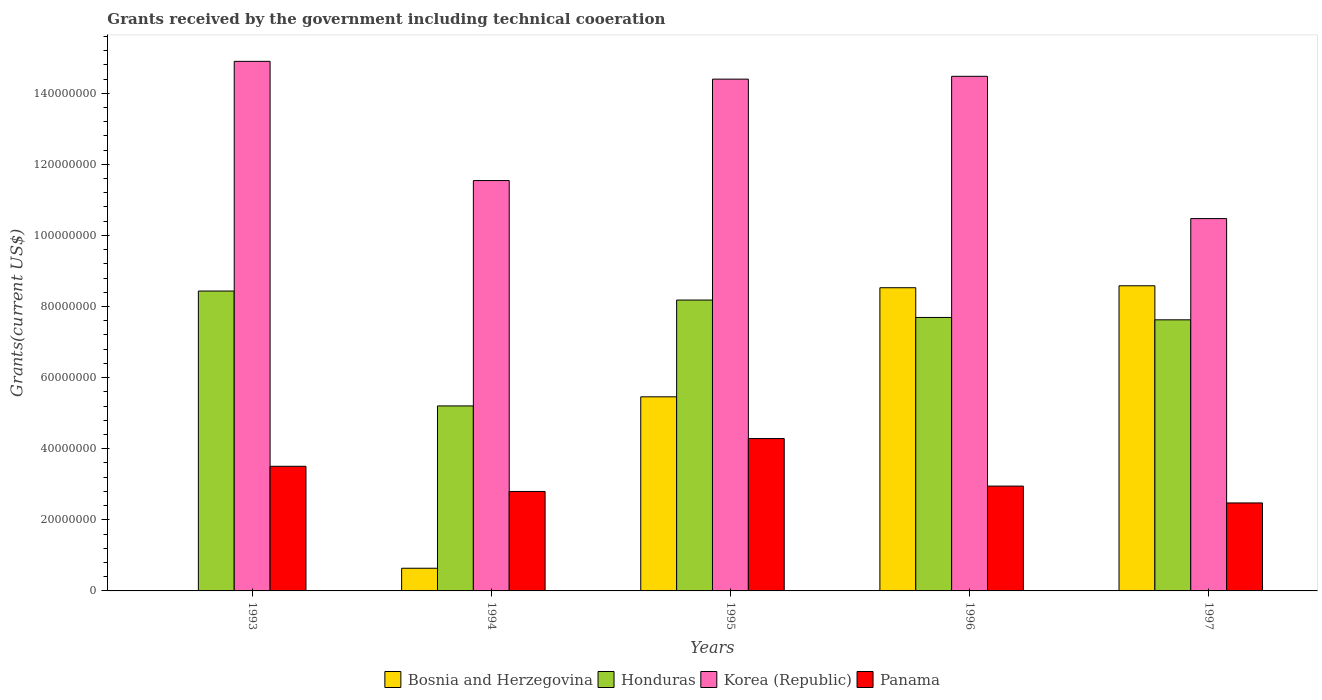Are the number of bars per tick equal to the number of legend labels?
Give a very brief answer. Yes. What is the label of the 4th group of bars from the left?
Provide a short and direct response. 1996. In how many cases, is the number of bars for a given year not equal to the number of legend labels?
Make the answer very short. 0. What is the total grants received by the government in Honduras in 1993?
Make the answer very short. 8.44e+07. Across all years, what is the maximum total grants received by the government in Panama?
Ensure brevity in your answer.  4.29e+07. Across all years, what is the minimum total grants received by the government in Honduras?
Offer a terse response. 5.20e+07. What is the total total grants received by the government in Panama in the graph?
Keep it short and to the point. 1.60e+08. What is the difference between the total grants received by the government in Panama in 1994 and that in 1996?
Give a very brief answer. -1.51e+06. What is the difference between the total grants received by the government in Korea (Republic) in 1993 and the total grants received by the government in Honduras in 1994?
Your answer should be very brief. 9.69e+07. What is the average total grants received by the government in Honduras per year?
Give a very brief answer. 7.43e+07. In the year 1994, what is the difference between the total grants received by the government in Panama and total grants received by the government in Korea (Republic)?
Your answer should be very brief. -8.75e+07. In how many years, is the total grants received by the government in Honduras greater than 64000000 US$?
Give a very brief answer. 4. What is the ratio of the total grants received by the government in Panama in 1996 to that in 1997?
Provide a succinct answer. 1.19. Is the total grants received by the government in Honduras in 1993 less than that in 1995?
Give a very brief answer. No. What is the difference between the highest and the second highest total grants received by the government in Honduras?
Your answer should be very brief. 2.54e+06. What is the difference between the highest and the lowest total grants received by the government in Bosnia and Herzegovina?
Provide a succinct answer. 8.58e+07. In how many years, is the total grants received by the government in Bosnia and Herzegovina greater than the average total grants received by the government in Bosnia and Herzegovina taken over all years?
Ensure brevity in your answer.  3. Is it the case that in every year, the sum of the total grants received by the government in Bosnia and Herzegovina and total grants received by the government in Honduras is greater than the sum of total grants received by the government in Korea (Republic) and total grants received by the government in Panama?
Provide a short and direct response. No. What does the 1st bar from the left in 1994 represents?
Your answer should be compact. Bosnia and Herzegovina. How many bars are there?
Provide a short and direct response. 20. Are all the bars in the graph horizontal?
Give a very brief answer. No. What is the difference between two consecutive major ticks on the Y-axis?
Keep it short and to the point. 2.00e+07. Are the values on the major ticks of Y-axis written in scientific E-notation?
Your response must be concise. No. Does the graph contain any zero values?
Make the answer very short. No. Does the graph contain grids?
Provide a succinct answer. No. How are the legend labels stacked?
Your answer should be very brief. Horizontal. What is the title of the graph?
Provide a short and direct response. Grants received by the government including technical cooeration. Does "North America" appear as one of the legend labels in the graph?
Your response must be concise. No. What is the label or title of the X-axis?
Offer a terse response. Years. What is the label or title of the Y-axis?
Offer a terse response. Grants(current US$). What is the Grants(current US$) in Bosnia and Herzegovina in 1993?
Make the answer very short. 8.00e+04. What is the Grants(current US$) in Honduras in 1993?
Offer a very short reply. 8.44e+07. What is the Grants(current US$) of Korea (Republic) in 1993?
Offer a very short reply. 1.49e+08. What is the Grants(current US$) in Panama in 1993?
Give a very brief answer. 3.51e+07. What is the Grants(current US$) in Bosnia and Herzegovina in 1994?
Offer a very short reply. 6.38e+06. What is the Grants(current US$) of Honduras in 1994?
Provide a short and direct response. 5.20e+07. What is the Grants(current US$) of Korea (Republic) in 1994?
Your response must be concise. 1.15e+08. What is the Grants(current US$) of Panama in 1994?
Make the answer very short. 2.80e+07. What is the Grants(current US$) of Bosnia and Herzegovina in 1995?
Keep it short and to the point. 5.46e+07. What is the Grants(current US$) in Honduras in 1995?
Make the answer very short. 8.18e+07. What is the Grants(current US$) in Korea (Republic) in 1995?
Provide a succinct answer. 1.44e+08. What is the Grants(current US$) in Panama in 1995?
Your answer should be compact. 4.29e+07. What is the Grants(current US$) of Bosnia and Herzegovina in 1996?
Offer a very short reply. 8.53e+07. What is the Grants(current US$) in Honduras in 1996?
Your response must be concise. 7.69e+07. What is the Grants(current US$) in Korea (Republic) in 1996?
Offer a terse response. 1.45e+08. What is the Grants(current US$) of Panama in 1996?
Provide a short and direct response. 2.95e+07. What is the Grants(current US$) of Bosnia and Herzegovina in 1997?
Make the answer very short. 8.58e+07. What is the Grants(current US$) of Honduras in 1997?
Provide a succinct answer. 7.63e+07. What is the Grants(current US$) in Korea (Republic) in 1997?
Provide a short and direct response. 1.05e+08. What is the Grants(current US$) in Panama in 1997?
Your response must be concise. 2.48e+07. Across all years, what is the maximum Grants(current US$) in Bosnia and Herzegovina?
Ensure brevity in your answer.  8.58e+07. Across all years, what is the maximum Grants(current US$) of Honduras?
Keep it short and to the point. 8.44e+07. Across all years, what is the maximum Grants(current US$) in Korea (Republic)?
Keep it short and to the point. 1.49e+08. Across all years, what is the maximum Grants(current US$) of Panama?
Provide a short and direct response. 4.29e+07. Across all years, what is the minimum Grants(current US$) in Bosnia and Herzegovina?
Offer a terse response. 8.00e+04. Across all years, what is the minimum Grants(current US$) of Honduras?
Provide a succinct answer. 5.20e+07. Across all years, what is the minimum Grants(current US$) in Korea (Republic)?
Keep it short and to the point. 1.05e+08. Across all years, what is the minimum Grants(current US$) of Panama?
Ensure brevity in your answer.  2.48e+07. What is the total Grants(current US$) of Bosnia and Herzegovina in the graph?
Give a very brief answer. 2.32e+08. What is the total Grants(current US$) of Honduras in the graph?
Keep it short and to the point. 3.71e+08. What is the total Grants(current US$) of Korea (Republic) in the graph?
Offer a terse response. 6.58e+08. What is the total Grants(current US$) of Panama in the graph?
Give a very brief answer. 1.60e+08. What is the difference between the Grants(current US$) in Bosnia and Herzegovina in 1993 and that in 1994?
Your answer should be very brief. -6.30e+06. What is the difference between the Grants(current US$) of Honduras in 1993 and that in 1994?
Your answer should be very brief. 3.23e+07. What is the difference between the Grants(current US$) in Korea (Republic) in 1993 and that in 1994?
Provide a succinct answer. 3.35e+07. What is the difference between the Grants(current US$) in Panama in 1993 and that in 1994?
Provide a succinct answer. 7.08e+06. What is the difference between the Grants(current US$) of Bosnia and Herzegovina in 1993 and that in 1995?
Provide a succinct answer. -5.45e+07. What is the difference between the Grants(current US$) of Honduras in 1993 and that in 1995?
Make the answer very short. 2.54e+06. What is the difference between the Grants(current US$) in Korea (Republic) in 1993 and that in 1995?
Provide a short and direct response. 5.00e+06. What is the difference between the Grants(current US$) in Panama in 1993 and that in 1995?
Make the answer very short. -7.80e+06. What is the difference between the Grants(current US$) of Bosnia and Herzegovina in 1993 and that in 1996?
Your answer should be compact. -8.52e+07. What is the difference between the Grants(current US$) of Honduras in 1993 and that in 1996?
Provide a short and direct response. 7.43e+06. What is the difference between the Grants(current US$) of Korea (Republic) in 1993 and that in 1996?
Offer a very short reply. 4.21e+06. What is the difference between the Grants(current US$) in Panama in 1993 and that in 1996?
Offer a terse response. 5.57e+06. What is the difference between the Grants(current US$) in Bosnia and Herzegovina in 1993 and that in 1997?
Offer a very short reply. -8.58e+07. What is the difference between the Grants(current US$) in Honduras in 1993 and that in 1997?
Provide a succinct answer. 8.10e+06. What is the difference between the Grants(current US$) of Korea (Republic) in 1993 and that in 1997?
Your answer should be very brief. 4.42e+07. What is the difference between the Grants(current US$) in Panama in 1993 and that in 1997?
Keep it short and to the point. 1.03e+07. What is the difference between the Grants(current US$) of Bosnia and Herzegovina in 1994 and that in 1995?
Your answer should be compact. -4.82e+07. What is the difference between the Grants(current US$) of Honduras in 1994 and that in 1995?
Your answer should be very brief. -2.98e+07. What is the difference between the Grants(current US$) in Korea (Republic) in 1994 and that in 1995?
Offer a terse response. -2.85e+07. What is the difference between the Grants(current US$) of Panama in 1994 and that in 1995?
Ensure brevity in your answer.  -1.49e+07. What is the difference between the Grants(current US$) of Bosnia and Herzegovina in 1994 and that in 1996?
Offer a very short reply. -7.89e+07. What is the difference between the Grants(current US$) of Honduras in 1994 and that in 1996?
Your response must be concise. -2.49e+07. What is the difference between the Grants(current US$) in Korea (Republic) in 1994 and that in 1996?
Provide a short and direct response. -2.93e+07. What is the difference between the Grants(current US$) of Panama in 1994 and that in 1996?
Your answer should be very brief. -1.51e+06. What is the difference between the Grants(current US$) in Bosnia and Herzegovina in 1994 and that in 1997?
Your answer should be compact. -7.95e+07. What is the difference between the Grants(current US$) in Honduras in 1994 and that in 1997?
Offer a terse response. -2.42e+07. What is the difference between the Grants(current US$) of Korea (Republic) in 1994 and that in 1997?
Your response must be concise. 1.07e+07. What is the difference between the Grants(current US$) in Panama in 1994 and that in 1997?
Offer a very short reply. 3.23e+06. What is the difference between the Grants(current US$) of Bosnia and Herzegovina in 1995 and that in 1996?
Provide a succinct answer. -3.07e+07. What is the difference between the Grants(current US$) in Honduras in 1995 and that in 1996?
Your answer should be very brief. 4.89e+06. What is the difference between the Grants(current US$) in Korea (Republic) in 1995 and that in 1996?
Keep it short and to the point. -7.90e+05. What is the difference between the Grants(current US$) in Panama in 1995 and that in 1996?
Make the answer very short. 1.34e+07. What is the difference between the Grants(current US$) of Bosnia and Herzegovina in 1995 and that in 1997?
Give a very brief answer. -3.12e+07. What is the difference between the Grants(current US$) in Honduras in 1995 and that in 1997?
Make the answer very short. 5.56e+06. What is the difference between the Grants(current US$) in Korea (Republic) in 1995 and that in 1997?
Ensure brevity in your answer.  3.92e+07. What is the difference between the Grants(current US$) of Panama in 1995 and that in 1997?
Provide a succinct answer. 1.81e+07. What is the difference between the Grants(current US$) in Bosnia and Herzegovina in 1996 and that in 1997?
Provide a short and direct response. -5.50e+05. What is the difference between the Grants(current US$) of Honduras in 1996 and that in 1997?
Make the answer very short. 6.70e+05. What is the difference between the Grants(current US$) of Korea (Republic) in 1996 and that in 1997?
Give a very brief answer. 4.00e+07. What is the difference between the Grants(current US$) in Panama in 1996 and that in 1997?
Your answer should be compact. 4.74e+06. What is the difference between the Grants(current US$) in Bosnia and Herzegovina in 1993 and the Grants(current US$) in Honduras in 1994?
Offer a very short reply. -5.20e+07. What is the difference between the Grants(current US$) in Bosnia and Herzegovina in 1993 and the Grants(current US$) in Korea (Republic) in 1994?
Provide a short and direct response. -1.15e+08. What is the difference between the Grants(current US$) in Bosnia and Herzegovina in 1993 and the Grants(current US$) in Panama in 1994?
Your answer should be very brief. -2.79e+07. What is the difference between the Grants(current US$) of Honduras in 1993 and the Grants(current US$) of Korea (Republic) in 1994?
Your response must be concise. -3.11e+07. What is the difference between the Grants(current US$) of Honduras in 1993 and the Grants(current US$) of Panama in 1994?
Provide a succinct answer. 5.64e+07. What is the difference between the Grants(current US$) in Korea (Republic) in 1993 and the Grants(current US$) in Panama in 1994?
Offer a very short reply. 1.21e+08. What is the difference between the Grants(current US$) of Bosnia and Herzegovina in 1993 and the Grants(current US$) of Honduras in 1995?
Offer a terse response. -8.17e+07. What is the difference between the Grants(current US$) in Bosnia and Herzegovina in 1993 and the Grants(current US$) in Korea (Republic) in 1995?
Your answer should be compact. -1.44e+08. What is the difference between the Grants(current US$) in Bosnia and Herzegovina in 1993 and the Grants(current US$) in Panama in 1995?
Give a very brief answer. -4.28e+07. What is the difference between the Grants(current US$) of Honduras in 1993 and the Grants(current US$) of Korea (Republic) in 1995?
Ensure brevity in your answer.  -5.96e+07. What is the difference between the Grants(current US$) of Honduras in 1993 and the Grants(current US$) of Panama in 1995?
Make the answer very short. 4.15e+07. What is the difference between the Grants(current US$) of Korea (Republic) in 1993 and the Grants(current US$) of Panama in 1995?
Offer a very short reply. 1.06e+08. What is the difference between the Grants(current US$) in Bosnia and Herzegovina in 1993 and the Grants(current US$) in Honduras in 1996?
Your response must be concise. -7.68e+07. What is the difference between the Grants(current US$) in Bosnia and Herzegovina in 1993 and the Grants(current US$) in Korea (Republic) in 1996?
Offer a very short reply. -1.45e+08. What is the difference between the Grants(current US$) in Bosnia and Herzegovina in 1993 and the Grants(current US$) in Panama in 1996?
Provide a short and direct response. -2.94e+07. What is the difference between the Grants(current US$) of Honduras in 1993 and the Grants(current US$) of Korea (Republic) in 1996?
Provide a succinct answer. -6.04e+07. What is the difference between the Grants(current US$) in Honduras in 1993 and the Grants(current US$) in Panama in 1996?
Your answer should be very brief. 5.49e+07. What is the difference between the Grants(current US$) of Korea (Republic) in 1993 and the Grants(current US$) of Panama in 1996?
Give a very brief answer. 1.19e+08. What is the difference between the Grants(current US$) of Bosnia and Herzegovina in 1993 and the Grants(current US$) of Honduras in 1997?
Provide a short and direct response. -7.62e+07. What is the difference between the Grants(current US$) of Bosnia and Herzegovina in 1993 and the Grants(current US$) of Korea (Republic) in 1997?
Your response must be concise. -1.05e+08. What is the difference between the Grants(current US$) of Bosnia and Herzegovina in 1993 and the Grants(current US$) of Panama in 1997?
Provide a short and direct response. -2.47e+07. What is the difference between the Grants(current US$) of Honduras in 1993 and the Grants(current US$) of Korea (Republic) in 1997?
Your answer should be very brief. -2.04e+07. What is the difference between the Grants(current US$) of Honduras in 1993 and the Grants(current US$) of Panama in 1997?
Your response must be concise. 5.96e+07. What is the difference between the Grants(current US$) of Korea (Republic) in 1993 and the Grants(current US$) of Panama in 1997?
Your answer should be very brief. 1.24e+08. What is the difference between the Grants(current US$) of Bosnia and Herzegovina in 1994 and the Grants(current US$) of Honduras in 1995?
Offer a very short reply. -7.54e+07. What is the difference between the Grants(current US$) of Bosnia and Herzegovina in 1994 and the Grants(current US$) of Korea (Republic) in 1995?
Your answer should be compact. -1.38e+08. What is the difference between the Grants(current US$) of Bosnia and Herzegovina in 1994 and the Grants(current US$) of Panama in 1995?
Offer a terse response. -3.65e+07. What is the difference between the Grants(current US$) in Honduras in 1994 and the Grants(current US$) in Korea (Republic) in 1995?
Make the answer very short. -9.19e+07. What is the difference between the Grants(current US$) of Honduras in 1994 and the Grants(current US$) of Panama in 1995?
Your answer should be very brief. 9.18e+06. What is the difference between the Grants(current US$) in Korea (Republic) in 1994 and the Grants(current US$) in Panama in 1995?
Your answer should be compact. 7.26e+07. What is the difference between the Grants(current US$) of Bosnia and Herzegovina in 1994 and the Grants(current US$) of Honduras in 1996?
Make the answer very short. -7.06e+07. What is the difference between the Grants(current US$) of Bosnia and Herzegovina in 1994 and the Grants(current US$) of Korea (Republic) in 1996?
Offer a terse response. -1.38e+08. What is the difference between the Grants(current US$) in Bosnia and Herzegovina in 1994 and the Grants(current US$) in Panama in 1996?
Ensure brevity in your answer.  -2.31e+07. What is the difference between the Grants(current US$) of Honduras in 1994 and the Grants(current US$) of Korea (Republic) in 1996?
Make the answer very short. -9.27e+07. What is the difference between the Grants(current US$) in Honduras in 1994 and the Grants(current US$) in Panama in 1996?
Your answer should be compact. 2.26e+07. What is the difference between the Grants(current US$) in Korea (Republic) in 1994 and the Grants(current US$) in Panama in 1996?
Your answer should be compact. 8.60e+07. What is the difference between the Grants(current US$) in Bosnia and Herzegovina in 1994 and the Grants(current US$) in Honduras in 1997?
Keep it short and to the point. -6.99e+07. What is the difference between the Grants(current US$) of Bosnia and Herzegovina in 1994 and the Grants(current US$) of Korea (Republic) in 1997?
Ensure brevity in your answer.  -9.84e+07. What is the difference between the Grants(current US$) of Bosnia and Herzegovina in 1994 and the Grants(current US$) of Panama in 1997?
Provide a short and direct response. -1.84e+07. What is the difference between the Grants(current US$) in Honduras in 1994 and the Grants(current US$) in Korea (Republic) in 1997?
Provide a succinct answer. -5.27e+07. What is the difference between the Grants(current US$) of Honduras in 1994 and the Grants(current US$) of Panama in 1997?
Ensure brevity in your answer.  2.73e+07. What is the difference between the Grants(current US$) in Korea (Republic) in 1994 and the Grants(current US$) in Panama in 1997?
Provide a succinct answer. 9.07e+07. What is the difference between the Grants(current US$) in Bosnia and Herzegovina in 1995 and the Grants(current US$) in Honduras in 1996?
Ensure brevity in your answer.  -2.23e+07. What is the difference between the Grants(current US$) in Bosnia and Herzegovina in 1995 and the Grants(current US$) in Korea (Republic) in 1996?
Your response must be concise. -9.02e+07. What is the difference between the Grants(current US$) in Bosnia and Herzegovina in 1995 and the Grants(current US$) in Panama in 1996?
Make the answer very short. 2.51e+07. What is the difference between the Grants(current US$) of Honduras in 1995 and the Grants(current US$) of Korea (Republic) in 1996?
Your response must be concise. -6.29e+07. What is the difference between the Grants(current US$) in Honduras in 1995 and the Grants(current US$) in Panama in 1996?
Keep it short and to the point. 5.23e+07. What is the difference between the Grants(current US$) in Korea (Republic) in 1995 and the Grants(current US$) in Panama in 1996?
Offer a very short reply. 1.14e+08. What is the difference between the Grants(current US$) of Bosnia and Herzegovina in 1995 and the Grants(current US$) of Honduras in 1997?
Ensure brevity in your answer.  -2.17e+07. What is the difference between the Grants(current US$) in Bosnia and Herzegovina in 1995 and the Grants(current US$) in Korea (Republic) in 1997?
Ensure brevity in your answer.  -5.01e+07. What is the difference between the Grants(current US$) in Bosnia and Herzegovina in 1995 and the Grants(current US$) in Panama in 1997?
Keep it short and to the point. 2.98e+07. What is the difference between the Grants(current US$) in Honduras in 1995 and the Grants(current US$) in Korea (Republic) in 1997?
Offer a terse response. -2.29e+07. What is the difference between the Grants(current US$) in Honduras in 1995 and the Grants(current US$) in Panama in 1997?
Offer a very short reply. 5.71e+07. What is the difference between the Grants(current US$) in Korea (Republic) in 1995 and the Grants(current US$) in Panama in 1997?
Keep it short and to the point. 1.19e+08. What is the difference between the Grants(current US$) of Bosnia and Herzegovina in 1996 and the Grants(current US$) of Honduras in 1997?
Your response must be concise. 9.03e+06. What is the difference between the Grants(current US$) of Bosnia and Herzegovina in 1996 and the Grants(current US$) of Korea (Republic) in 1997?
Offer a very short reply. -1.94e+07. What is the difference between the Grants(current US$) in Bosnia and Herzegovina in 1996 and the Grants(current US$) in Panama in 1997?
Your answer should be compact. 6.05e+07. What is the difference between the Grants(current US$) of Honduras in 1996 and the Grants(current US$) of Korea (Republic) in 1997?
Your answer should be compact. -2.78e+07. What is the difference between the Grants(current US$) of Honduras in 1996 and the Grants(current US$) of Panama in 1997?
Offer a terse response. 5.22e+07. What is the difference between the Grants(current US$) of Korea (Republic) in 1996 and the Grants(current US$) of Panama in 1997?
Ensure brevity in your answer.  1.20e+08. What is the average Grants(current US$) of Bosnia and Herzegovina per year?
Keep it short and to the point. 4.64e+07. What is the average Grants(current US$) in Honduras per year?
Provide a short and direct response. 7.43e+07. What is the average Grants(current US$) of Korea (Republic) per year?
Provide a succinct answer. 1.32e+08. What is the average Grants(current US$) in Panama per year?
Provide a succinct answer. 3.20e+07. In the year 1993, what is the difference between the Grants(current US$) in Bosnia and Herzegovina and Grants(current US$) in Honduras?
Offer a terse response. -8.43e+07. In the year 1993, what is the difference between the Grants(current US$) in Bosnia and Herzegovina and Grants(current US$) in Korea (Republic)?
Ensure brevity in your answer.  -1.49e+08. In the year 1993, what is the difference between the Grants(current US$) in Bosnia and Herzegovina and Grants(current US$) in Panama?
Offer a very short reply. -3.50e+07. In the year 1993, what is the difference between the Grants(current US$) in Honduras and Grants(current US$) in Korea (Republic)?
Provide a succinct answer. -6.46e+07. In the year 1993, what is the difference between the Grants(current US$) of Honduras and Grants(current US$) of Panama?
Keep it short and to the point. 4.93e+07. In the year 1993, what is the difference between the Grants(current US$) of Korea (Republic) and Grants(current US$) of Panama?
Offer a terse response. 1.14e+08. In the year 1994, what is the difference between the Grants(current US$) in Bosnia and Herzegovina and Grants(current US$) in Honduras?
Offer a very short reply. -4.57e+07. In the year 1994, what is the difference between the Grants(current US$) of Bosnia and Herzegovina and Grants(current US$) of Korea (Republic)?
Keep it short and to the point. -1.09e+08. In the year 1994, what is the difference between the Grants(current US$) in Bosnia and Herzegovina and Grants(current US$) in Panama?
Provide a succinct answer. -2.16e+07. In the year 1994, what is the difference between the Grants(current US$) of Honduras and Grants(current US$) of Korea (Republic)?
Your response must be concise. -6.34e+07. In the year 1994, what is the difference between the Grants(current US$) of Honduras and Grants(current US$) of Panama?
Your answer should be compact. 2.41e+07. In the year 1994, what is the difference between the Grants(current US$) in Korea (Republic) and Grants(current US$) in Panama?
Offer a terse response. 8.75e+07. In the year 1995, what is the difference between the Grants(current US$) of Bosnia and Herzegovina and Grants(current US$) of Honduras?
Give a very brief answer. -2.72e+07. In the year 1995, what is the difference between the Grants(current US$) in Bosnia and Herzegovina and Grants(current US$) in Korea (Republic)?
Offer a very short reply. -8.94e+07. In the year 1995, what is the difference between the Grants(current US$) of Bosnia and Herzegovina and Grants(current US$) of Panama?
Make the answer very short. 1.17e+07. In the year 1995, what is the difference between the Grants(current US$) in Honduras and Grants(current US$) in Korea (Republic)?
Provide a succinct answer. -6.22e+07. In the year 1995, what is the difference between the Grants(current US$) in Honduras and Grants(current US$) in Panama?
Offer a terse response. 3.90e+07. In the year 1995, what is the difference between the Grants(current US$) of Korea (Republic) and Grants(current US$) of Panama?
Offer a very short reply. 1.01e+08. In the year 1996, what is the difference between the Grants(current US$) of Bosnia and Herzegovina and Grants(current US$) of Honduras?
Your answer should be very brief. 8.36e+06. In the year 1996, what is the difference between the Grants(current US$) of Bosnia and Herzegovina and Grants(current US$) of Korea (Republic)?
Your answer should be very brief. -5.95e+07. In the year 1996, what is the difference between the Grants(current US$) of Bosnia and Herzegovina and Grants(current US$) of Panama?
Offer a terse response. 5.58e+07. In the year 1996, what is the difference between the Grants(current US$) in Honduras and Grants(current US$) in Korea (Republic)?
Make the answer very short. -6.78e+07. In the year 1996, what is the difference between the Grants(current US$) of Honduras and Grants(current US$) of Panama?
Keep it short and to the point. 4.74e+07. In the year 1996, what is the difference between the Grants(current US$) in Korea (Republic) and Grants(current US$) in Panama?
Offer a terse response. 1.15e+08. In the year 1997, what is the difference between the Grants(current US$) in Bosnia and Herzegovina and Grants(current US$) in Honduras?
Keep it short and to the point. 9.58e+06. In the year 1997, what is the difference between the Grants(current US$) in Bosnia and Herzegovina and Grants(current US$) in Korea (Republic)?
Offer a very short reply. -1.89e+07. In the year 1997, what is the difference between the Grants(current US$) of Bosnia and Herzegovina and Grants(current US$) of Panama?
Your answer should be compact. 6.11e+07. In the year 1997, what is the difference between the Grants(current US$) in Honduras and Grants(current US$) in Korea (Republic)?
Make the answer very short. -2.85e+07. In the year 1997, what is the difference between the Grants(current US$) in Honduras and Grants(current US$) in Panama?
Make the answer very short. 5.15e+07. In the year 1997, what is the difference between the Grants(current US$) in Korea (Republic) and Grants(current US$) in Panama?
Your answer should be compact. 8.00e+07. What is the ratio of the Grants(current US$) in Bosnia and Herzegovina in 1993 to that in 1994?
Give a very brief answer. 0.01. What is the ratio of the Grants(current US$) of Honduras in 1993 to that in 1994?
Make the answer very short. 1.62. What is the ratio of the Grants(current US$) in Korea (Republic) in 1993 to that in 1994?
Give a very brief answer. 1.29. What is the ratio of the Grants(current US$) of Panama in 1993 to that in 1994?
Ensure brevity in your answer.  1.25. What is the ratio of the Grants(current US$) of Bosnia and Herzegovina in 1993 to that in 1995?
Keep it short and to the point. 0. What is the ratio of the Grants(current US$) of Honduras in 1993 to that in 1995?
Give a very brief answer. 1.03. What is the ratio of the Grants(current US$) in Korea (Republic) in 1993 to that in 1995?
Your answer should be very brief. 1.03. What is the ratio of the Grants(current US$) of Panama in 1993 to that in 1995?
Offer a terse response. 0.82. What is the ratio of the Grants(current US$) of Bosnia and Herzegovina in 1993 to that in 1996?
Make the answer very short. 0. What is the ratio of the Grants(current US$) of Honduras in 1993 to that in 1996?
Offer a very short reply. 1.1. What is the ratio of the Grants(current US$) of Korea (Republic) in 1993 to that in 1996?
Ensure brevity in your answer.  1.03. What is the ratio of the Grants(current US$) in Panama in 1993 to that in 1996?
Make the answer very short. 1.19. What is the ratio of the Grants(current US$) of Bosnia and Herzegovina in 1993 to that in 1997?
Offer a terse response. 0. What is the ratio of the Grants(current US$) of Honduras in 1993 to that in 1997?
Offer a terse response. 1.11. What is the ratio of the Grants(current US$) of Korea (Republic) in 1993 to that in 1997?
Make the answer very short. 1.42. What is the ratio of the Grants(current US$) of Panama in 1993 to that in 1997?
Keep it short and to the point. 1.42. What is the ratio of the Grants(current US$) of Bosnia and Herzegovina in 1994 to that in 1995?
Keep it short and to the point. 0.12. What is the ratio of the Grants(current US$) in Honduras in 1994 to that in 1995?
Provide a succinct answer. 0.64. What is the ratio of the Grants(current US$) of Korea (Republic) in 1994 to that in 1995?
Your answer should be compact. 0.8. What is the ratio of the Grants(current US$) of Panama in 1994 to that in 1995?
Offer a terse response. 0.65. What is the ratio of the Grants(current US$) of Bosnia and Herzegovina in 1994 to that in 1996?
Keep it short and to the point. 0.07. What is the ratio of the Grants(current US$) of Honduras in 1994 to that in 1996?
Your answer should be compact. 0.68. What is the ratio of the Grants(current US$) of Korea (Republic) in 1994 to that in 1996?
Offer a very short reply. 0.8. What is the ratio of the Grants(current US$) of Panama in 1994 to that in 1996?
Make the answer very short. 0.95. What is the ratio of the Grants(current US$) in Bosnia and Herzegovina in 1994 to that in 1997?
Ensure brevity in your answer.  0.07. What is the ratio of the Grants(current US$) of Honduras in 1994 to that in 1997?
Make the answer very short. 0.68. What is the ratio of the Grants(current US$) in Korea (Republic) in 1994 to that in 1997?
Give a very brief answer. 1.1. What is the ratio of the Grants(current US$) in Panama in 1994 to that in 1997?
Give a very brief answer. 1.13. What is the ratio of the Grants(current US$) of Bosnia and Herzegovina in 1995 to that in 1996?
Your answer should be very brief. 0.64. What is the ratio of the Grants(current US$) of Honduras in 1995 to that in 1996?
Make the answer very short. 1.06. What is the ratio of the Grants(current US$) of Panama in 1995 to that in 1996?
Ensure brevity in your answer.  1.45. What is the ratio of the Grants(current US$) in Bosnia and Herzegovina in 1995 to that in 1997?
Provide a succinct answer. 0.64. What is the ratio of the Grants(current US$) in Honduras in 1995 to that in 1997?
Offer a very short reply. 1.07. What is the ratio of the Grants(current US$) in Korea (Republic) in 1995 to that in 1997?
Keep it short and to the point. 1.37. What is the ratio of the Grants(current US$) of Panama in 1995 to that in 1997?
Give a very brief answer. 1.73. What is the ratio of the Grants(current US$) of Honduras in 1996 to that in 1997?
Provide a succinct answer. 1.01. What is the ratio of the Grants(current US$) of Korea (Republic) in 1996 to that in 1997?
Give a very brief answer. 1.38. What is the ratio of the Grants(current US$) in Panama in 1996 to that in 1997?
Your response must be concise. 1.19. What is the difference between the highest and the second highest Grants(current US$) in Honduras?
Your response must be concise. 2.54e+06. What is the difference between the highest and the second highest Grants(current US$) in Korea (Republic)?
Keep it short and to the point. 4.21e+06. What is the difference between the highest and the second highest Grants(current US$) of Panama?
Keep it short and to the point. 7.80e+06. What is the difference between the highest and the lowest Grants(current US$) of Bosnia and Herzegovina?
Offer a very short reply. 8.58e+07. What is the difference between the highest and the lowest Grants(current US$) of Honduras?
Offer a very short reply. 3.23e+07. What is the difference between the highest and the lowest Grants(current US$) in Korea (Republic)?
Ensure brevity in your answer.  4.42e+07. What is the difference between the highest and the lowest Grants(current US$) of Panama?
Your response must be concise. 1.81e+07. 